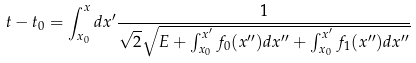<formula> <loc_0><loc_0><loc_500><loc_500>t - t _ { 0 } = \int _ { x _ { 0 } } ^ { x } d x ^ { \prime } \frac { 1 } { \sqrt { 2 } \sqrt { E + \int _ { x _ { 0 } } ^ { x ^ { \prime } } f _ { 0 } ( x ^ { \prime \prime } ) d x ^ { \prime \prime } + \int _ { x _ { 0 } } ^ { x ^ { \prime } } f _ { 1 } ( x ^ { \prime \prime } ) d x ^ { \prime \prime } } }</formula> 